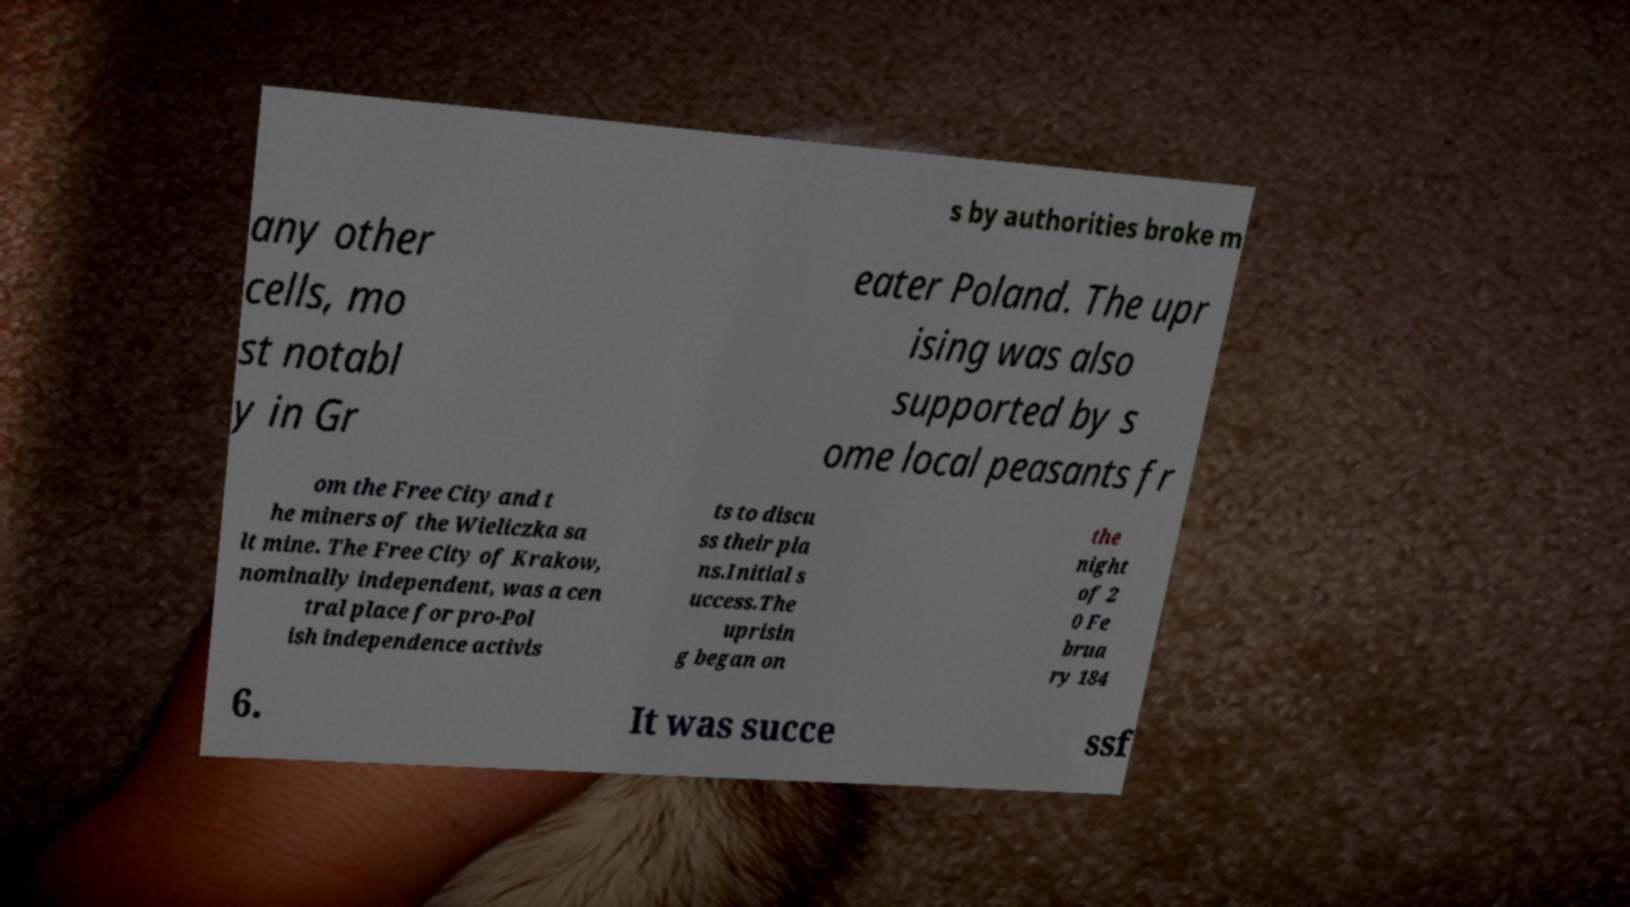Could you extract and type out the text from this image? s by authorities broke m any other cells, mo st notabl y in Gr eater Poland. The upr ising was also supported by s ome local peasants fr om the Free City and t he miners of the Wieliczka sa lt mine. The Free City of Krakow, nominally independent, was a cen tral place for pro-Pol ish independence activis ts to discu ss their pla ns.Initial s uccess.The uprisin g began on the night of 2 0 Fe brua ry 184 6. It was succe ssf 